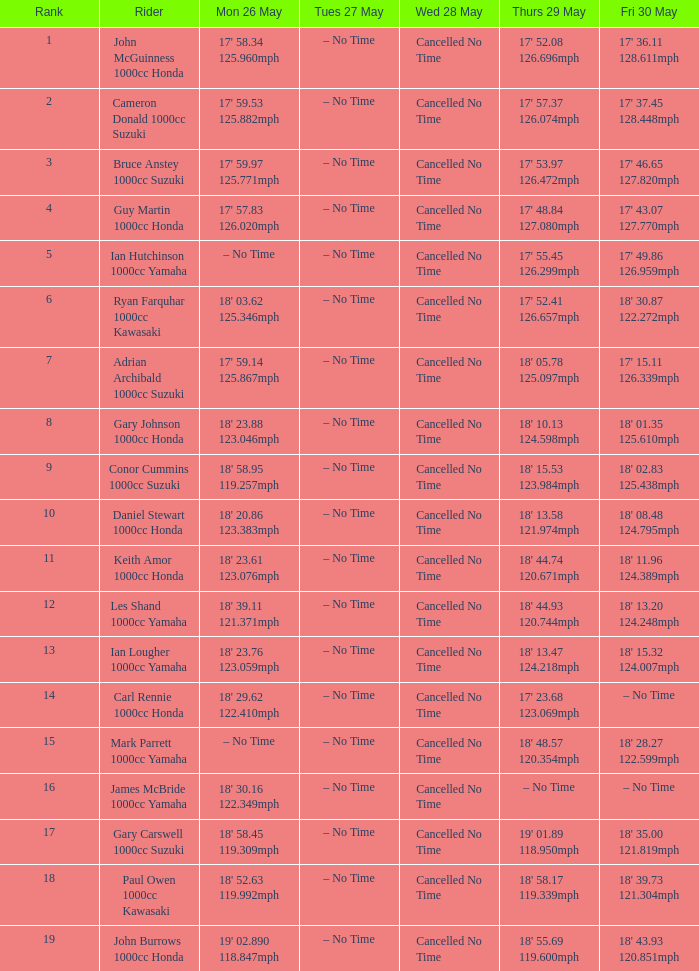At what moment is mon may 26 and fri may 30 at 18' 2 – No Time. 